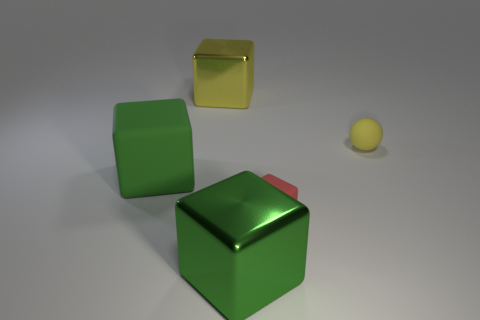Subtract all green matte cubes. How many cubes are left? 3 Add 3 brown rubber spheres. How many objects exist? 8 Subtract all balls. How many objects are left? 4 Subtract all blue cylinders. How many brown spheres are left? 0 Subtract all yellow matte objects. Subtract all purple things. How many objects are left? 4 Add 5 rubber balls. How many rubber balls are left? 6 Add 3 rubber cubes. How many rubber cubes exist? 5 Subtract all green blocks. How many blocks are left? 2 Subtract 2 green cubes. How many objects are left? 3 Subtract 2 blocks. How many blocks are left? 2 